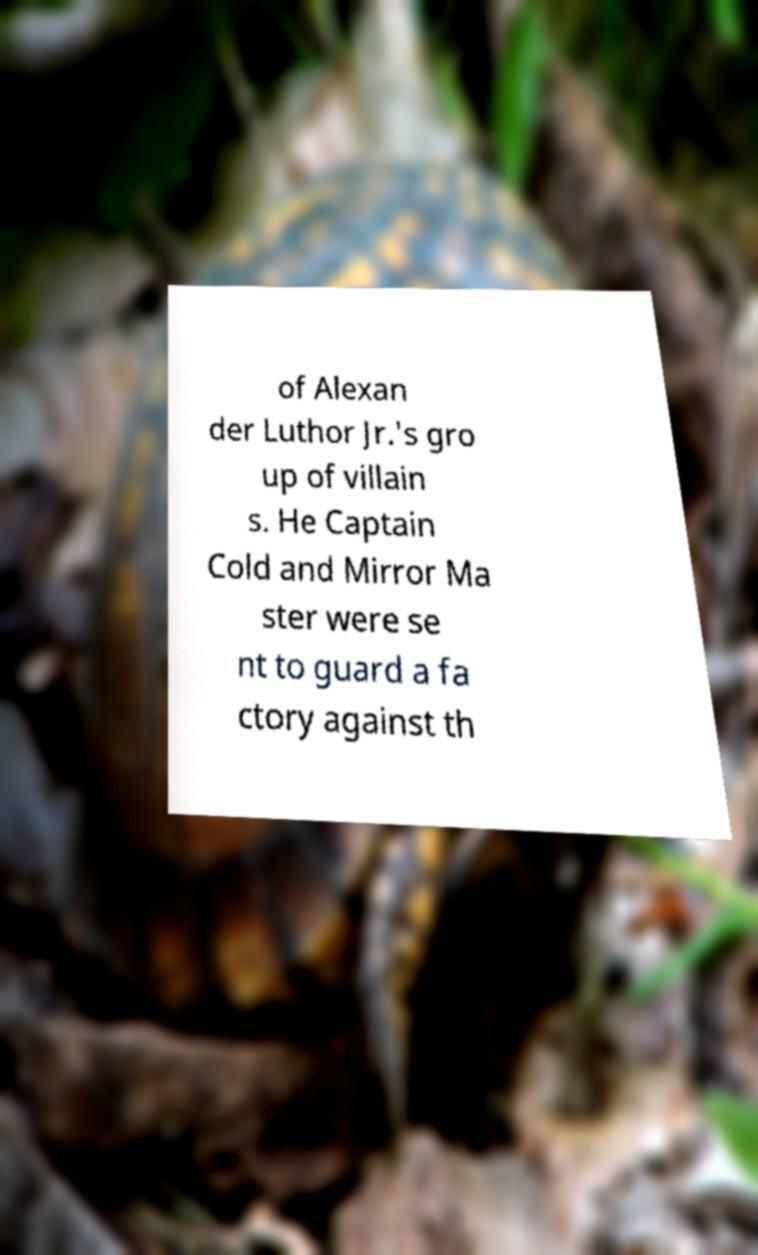Please read and relay the text visible in this image. What does it say? of Alexan der Luthor Jr.'s gro up of villain s. He Captain Cold and Mirror Ma ster were se nt to guard a fa ctory against th 